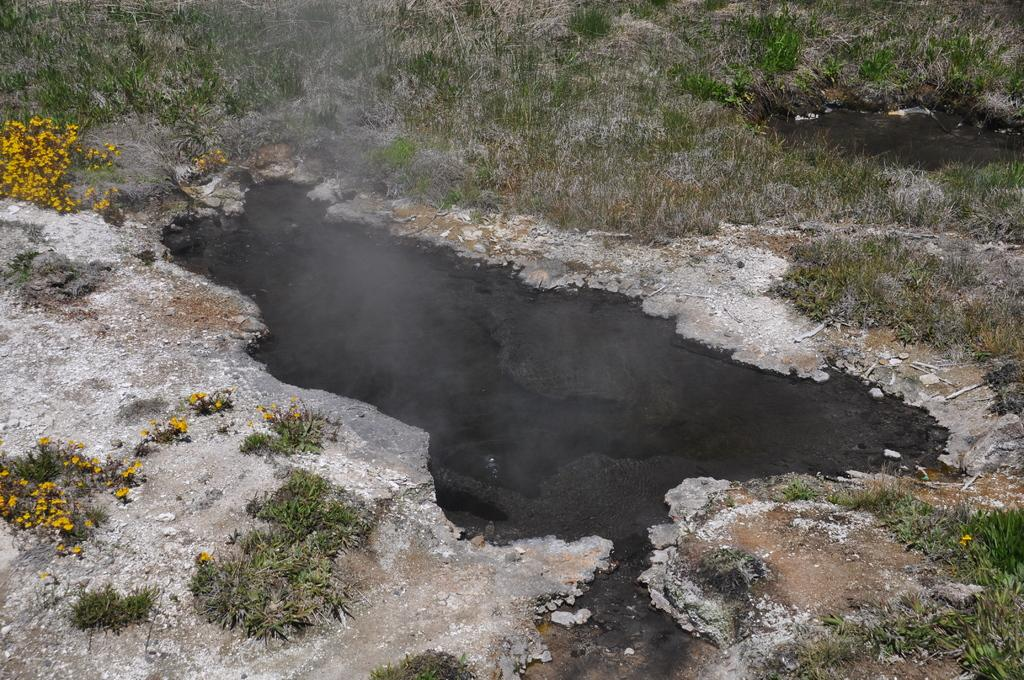What can be seen in the image that is not solid? There is water visible in the image. What type of flowers can be seen near the grass? There are yellow color flowers near the grass. What type of vegetation is visible in the image? There is grass visible in the image. What type of stocking is hanging on the tree in the image? There is no stocking present in the image. Where is the meeting taking place in the image? There is no meeting depicted in the image. Can you see a cat in the image? There is no cat present in the image. 